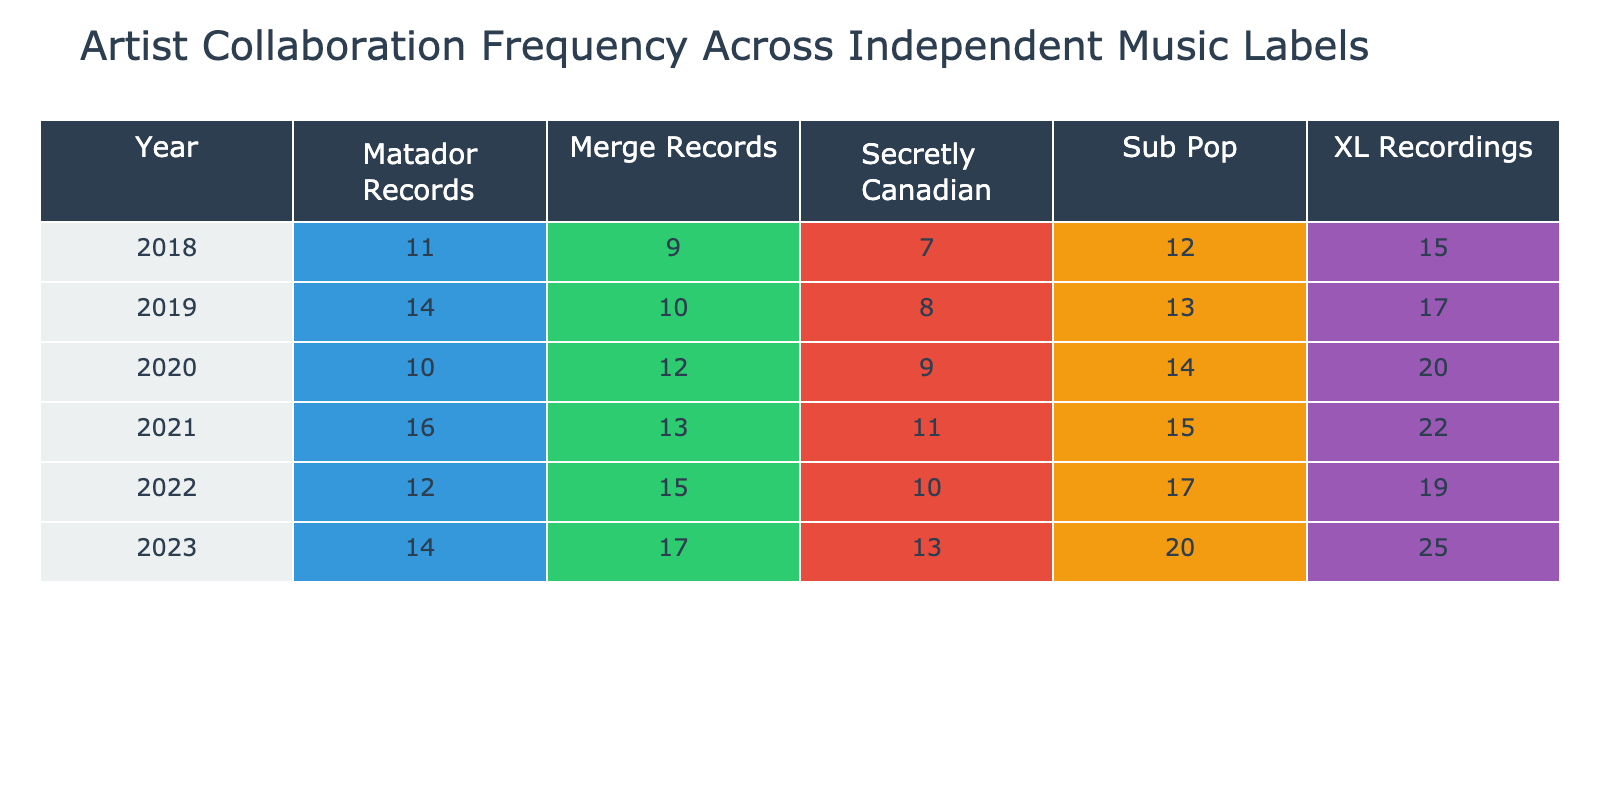What was the highest artist collaboration count for XL Recordings over the years? The table shows that the artist collaboration count for XL Recordings peaked at 25 in 2023.
Answer: 25 Which independent label had the lowest collaboration count in 2018? Looking at the 2018 data, Secretly Canadian had the lowest artist collaboration count with a total of 7.
Answer: 7 What is the total artist collaboration count for Merge Records from 2019 to 2021? By summing the counts for Merge Records over those years: 10 (2019) + 13 (2020) + 13 (2021) = 36.
Answer: 36 Did Sub Pop have a consistent increase in artist collaboration counts every year from 2018 to 2023? Examining the table, Sub Pop increased its collaboration count from 12 in 2018 to 20 in 2023, with counts of 13, 14, 15, and 17 in the intervening years, indicating consistent growth.
Answer: Yes What was the average artist collaboration count for Matador Records across all years? The total collaboration counts for Matador Records are 11 (2018), 14 (2019), 10 (2020), 16 (2021), 12 (2022), and 14 (2023). Summing these gives 77. There are 6 data points, so the average is 77 ÷ 6 = approximately 12.83.
Answer: 12.83 Compared to 2019, did XL Recordings increase or decrease artist collaborations in 2020? In 2019, XL Recordings had 17 collaborations, and in 2020, it increased to 20, indicating an increase.
Answer: Increase 